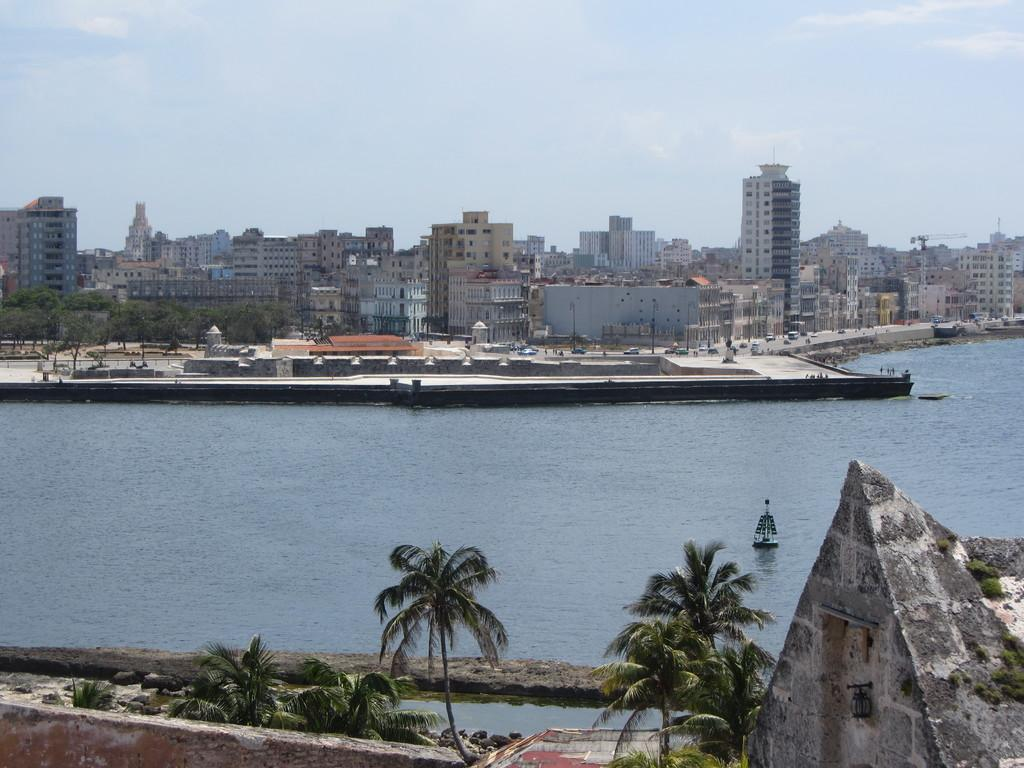What is the main subject of the image? The main subject of the image is a boat. Where is the boat located? The boat is on a river. What can be seen on either side of the river? There are trees and buildings on either side of the river. Where is the rabbit hiding on the shelf in the image? There is no rabbit or shelf present in the image. What color is the ball that is being thrown in the image? There is no ball present in the image. 